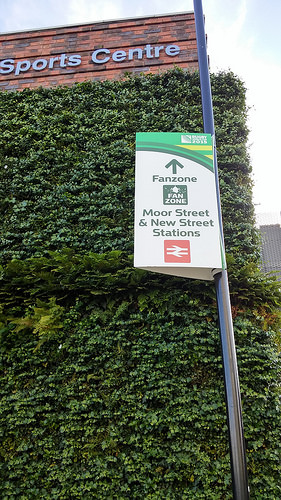<image>
Is there a board on the leaves? No. The board is not positioned on the leaves. They may be near each other, but the board is not supported by or resting on top of the leaves. 